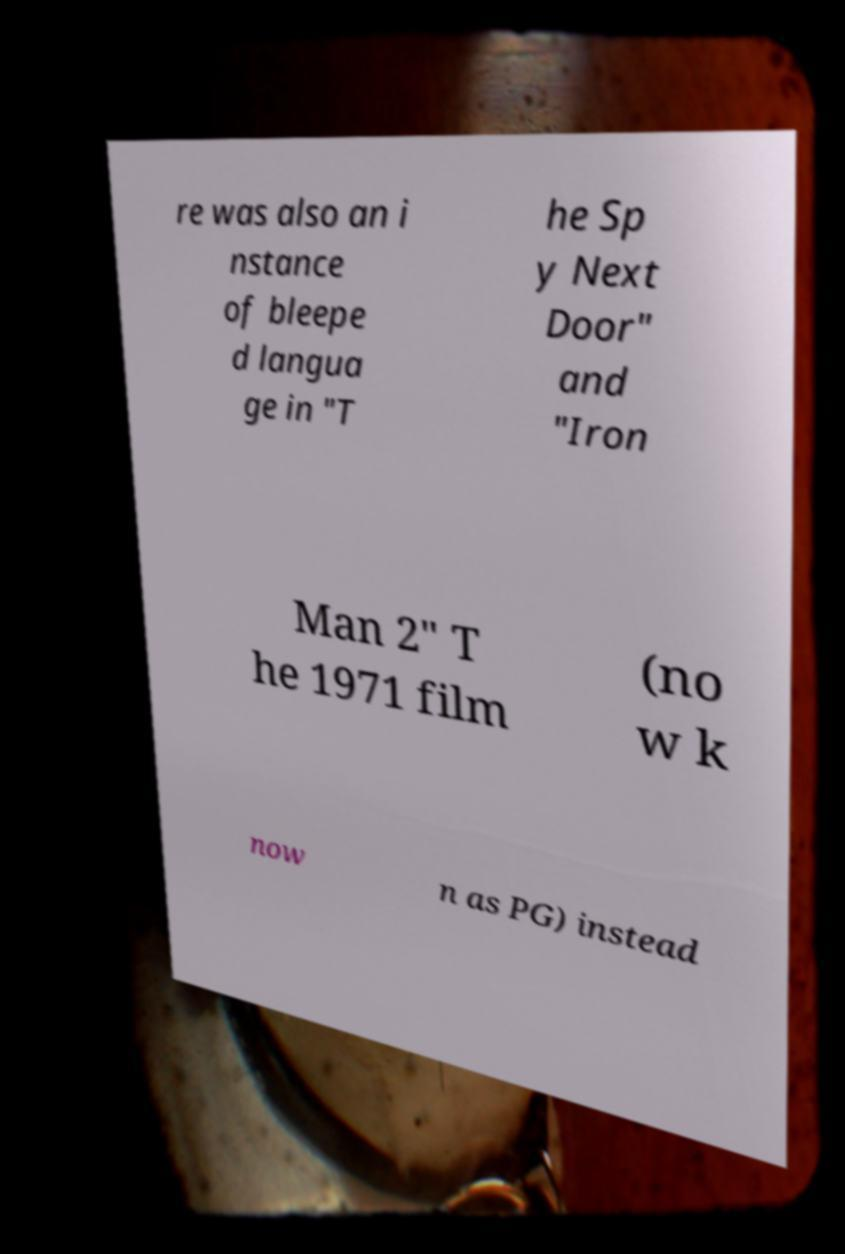Can you accurately transcribe the text from the provided image for me? re was also an i nstance of bleepe d langua ge in "T he Sp y Next Door" and "Iron Man 2" T he 1971 film (no w k now n as PG) instead 